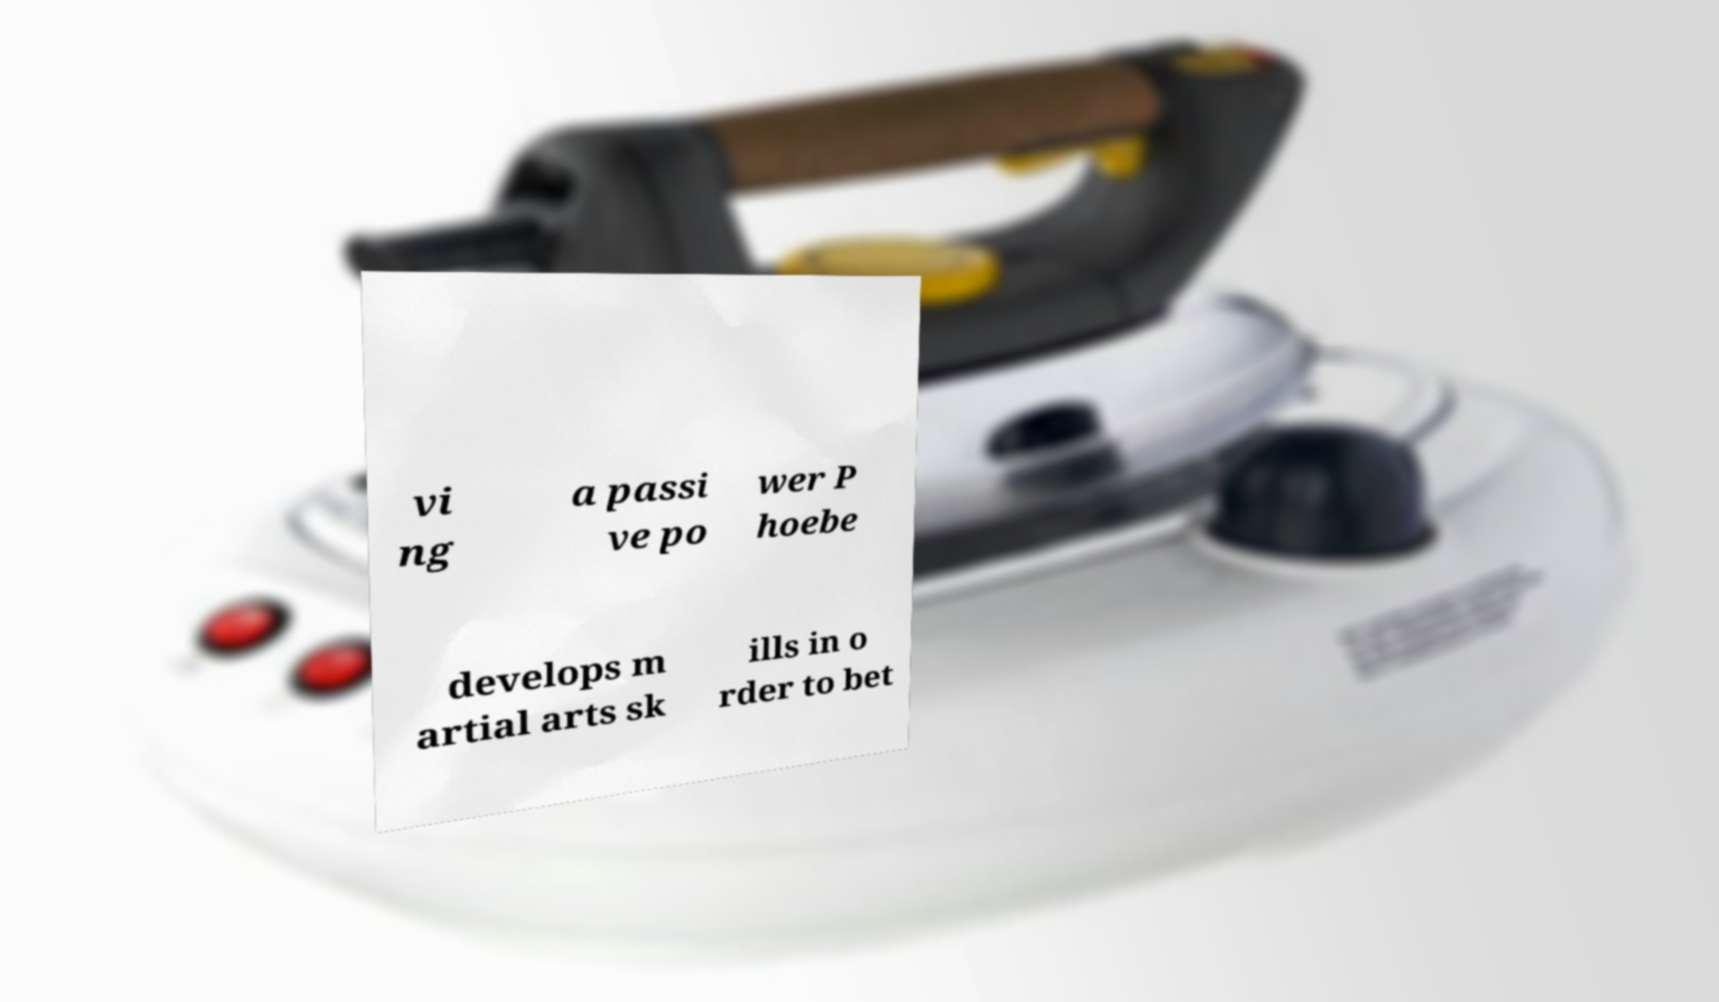For documentation purposes, I need the text within this image transcribed. Could you provide that? vi ng a passi ve po wer P hoebe develops m artial arts sk ills in o rder to bet 